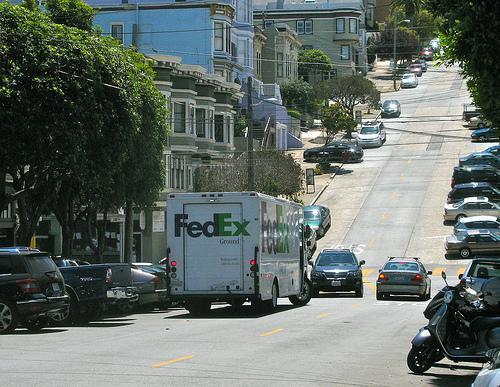How many pickup trucks are in the picture?
Give a very brief answer. 1. 